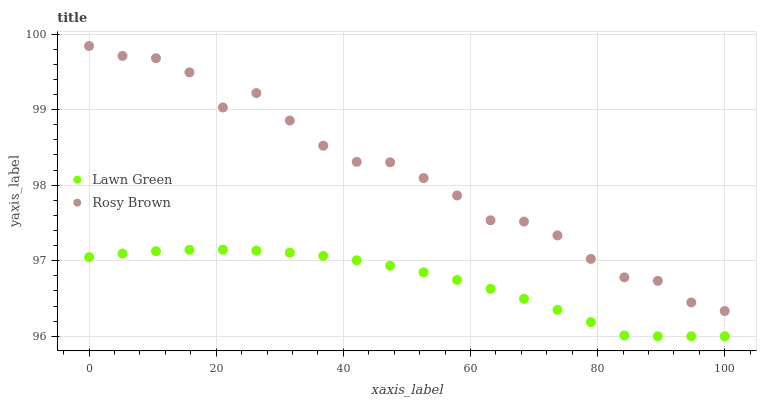Does Lawn Green have the minimum area under the curve?
Answer yes or no. Yes. Does Rosy Brown have the maximum area under the curve?
Answer yes or no. Yes. Does Rosy Brown have the minimum area under the curve?
Answer yes or no. No. Is Lawn Green the smoothest?
Answer yes or no. Yes. Is Rosy Brown the roughest?
Answer yes or no. Yes. Is Rosy Brown the smoothest?
Answer yes or no. No. Does Lawn Green have the lowest value?
Answer yes or no. Yes. Does Rosy Brown have the lowest value?
Answer yes or no. No. Does Rosy Brown have the highest value?
Answer yes or no. Yes. Is Lawn Green less than Rosy Brown?
Answer yes or no. Yes. Is Rosy Brown greater than Lawn Green?
Answer yes or no. Yes. Does Lawn Green intersect Rosy Brown?
Answer yes or no. No. 